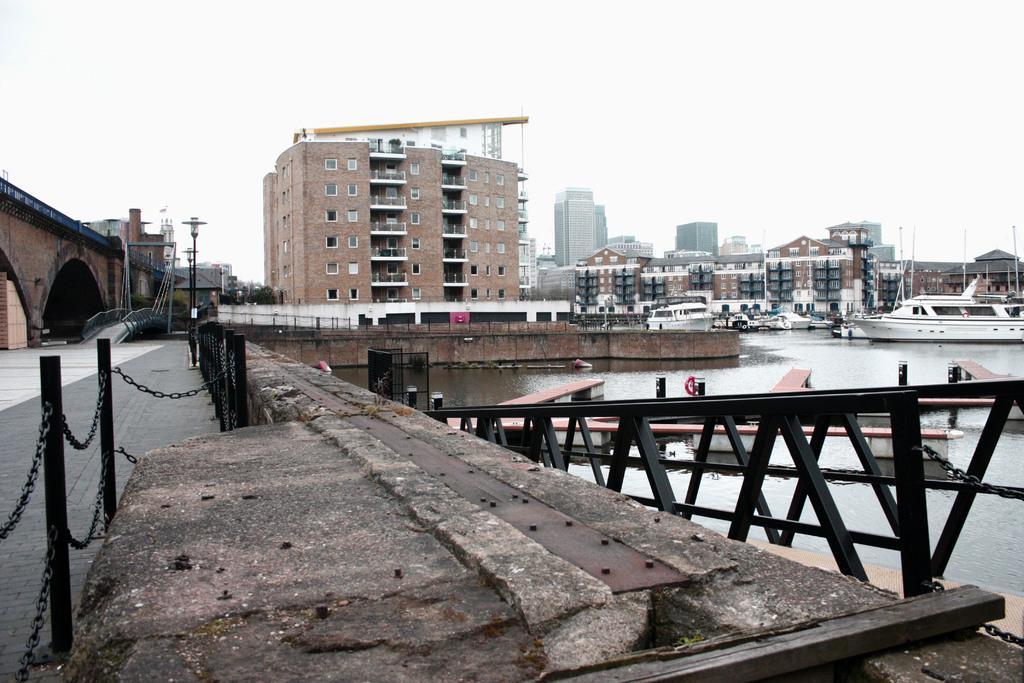Could you give a brief overview of what you see in this image? In the image there is a bridge and beside the bridge there is a water surface, on the water surface there are boats and in the background there are many buildings. 